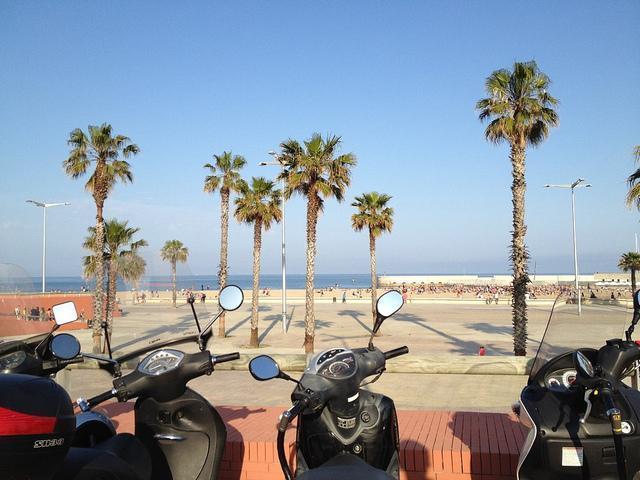How many scooters are there in this picture?
Give a very brief answer. 4. How many motorcycles are there?
Give a very brief answer. 3. 